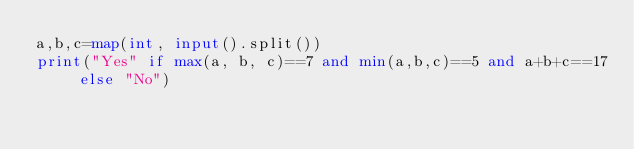<code> <loc_0><loc_0><loc_500><loc_500><_Python_>a,b,c=map(int, input().split())
print("Yes" if max(a, b, c)==7 and min(a,b,c)==5 and a+b+c==17 else "No")
</code> 